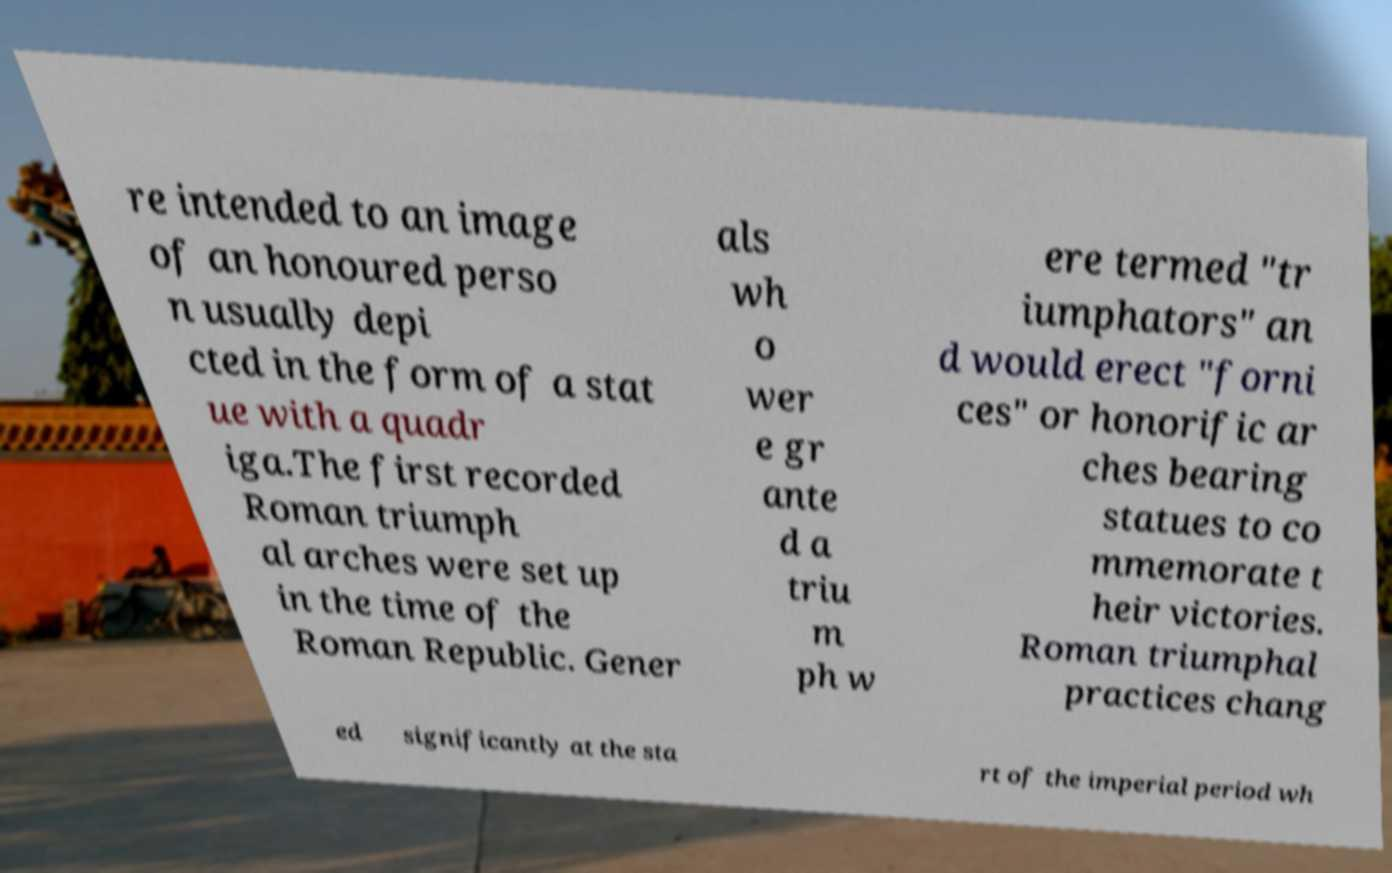Could you extract and type out the text from this image? re intended to an image of an honoured perso n usually depi cted in the form of a stat ue with a quadr iga.The first recorded Roman triumph al arches were set up in the time of the Roman Republic. Gener als wh o wer e gr ante d a triu m ph w ere termed "tr iumphators" an d would erect "forni ces" or honorific ar ches bearing statues to co mmemorate t heir victories. Roman triumphal practices chang ed significantly at the sta rt of the imperial period wh 